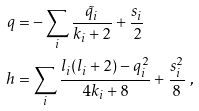<formula> <loc_0><loc_0><loc_500><loc_500>q & = - \sum _ { i } \frac { \tilde { q } _ { i } } { k _ { i } + 2 } + \frac { s _ { i } } { 2 } \\ h & = \sum _ { i } \frac { l _ { i } ( l _ { i } + 2 ) - q _ { i } ^ { 2 } } { 4 k _ { i } + 8 } + \frac { s _ { i } ^ { 2 } } { 8 } \ , \\</formula> 